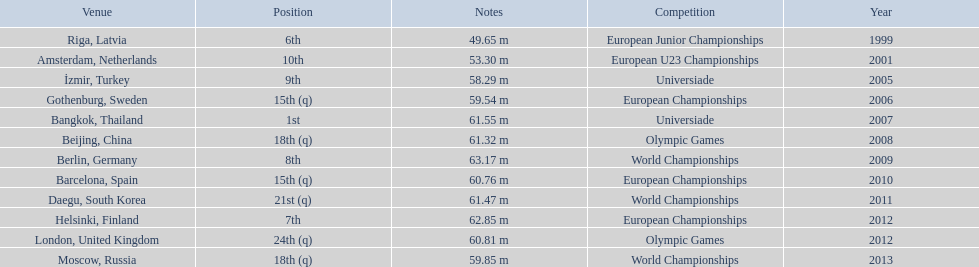What are all the competitions? European Junior Championships, European U23 Championships, Universiade, European Championships, Universiade, Olympic Games, World Championships, European Championships, World Championships, European Championships, Olympic Games, World Championships. What years did they place in the top 10? 1999, 2001, 2005, 2007, 2009, 2012. Besides when they placed first, which position was their highest? 6th. 